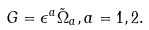Convert formula to latex. <formula><loc_0><loc_0><loc_500><loc_500>G = \epsilon ^ { a } \tilde { \Omega } _ { a } , a = 1 , 2 .</formula> 